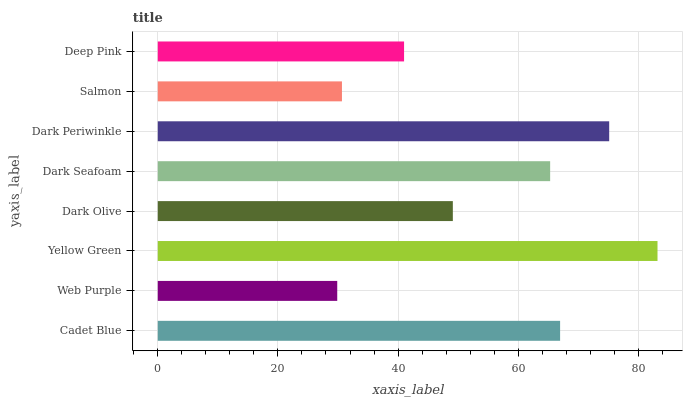Is Web Purple the minimum?
Answer yes or no. Yes. Is Yellow Green the maximum?
Answer yes or no. Yes. Is Yellow Green the minimum?
Answer yes or no. No. Is Web Purple the maximum?
Answer yes or no. No. Is Yellow Green greater than Web Purple?
Answer yes or no. Yes. Is Web Purple less than Yellow Green?
Answer yes or no. Yes. Is Web Purple greater than Yellow Green?
Answer yes or no. No. Is Yellow Green less than Web Purple?
Answer yes or no. No. Is Dark Seafoam the high median?
Answer yes or no. Yes. Is Dark Olive the low median?
Answer yes or no. Yes. Is Dark Periwinkle the high median?
Answer yes or no. No. Is Dark Seafoam the low median?
Answer yes or no. No. 